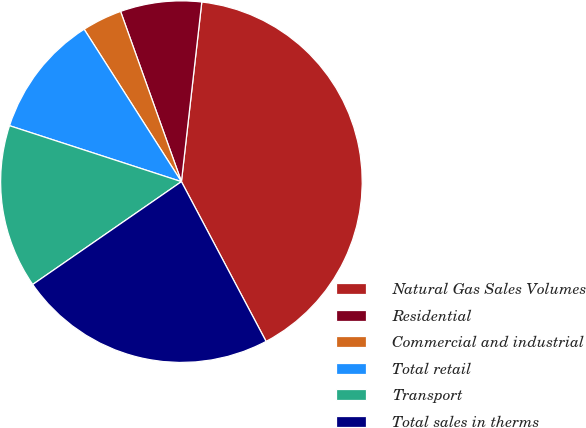Convert chart to OTSL. <chart><loc_0><loc_0><loc_500><loc_500><pie_chart><fcel>Natural Gas Sales Volumes<fcel>Residential<fcel>Commercial and industrial<fcel>Total retail<fcel>Transport<fcel>Total sales in therms<nl><fcel>40.45%<fcel>7.26%<fcel>3.58%<fcel>10.95%<fcel>14.64%<fcel>23.13%<nl></chart> 